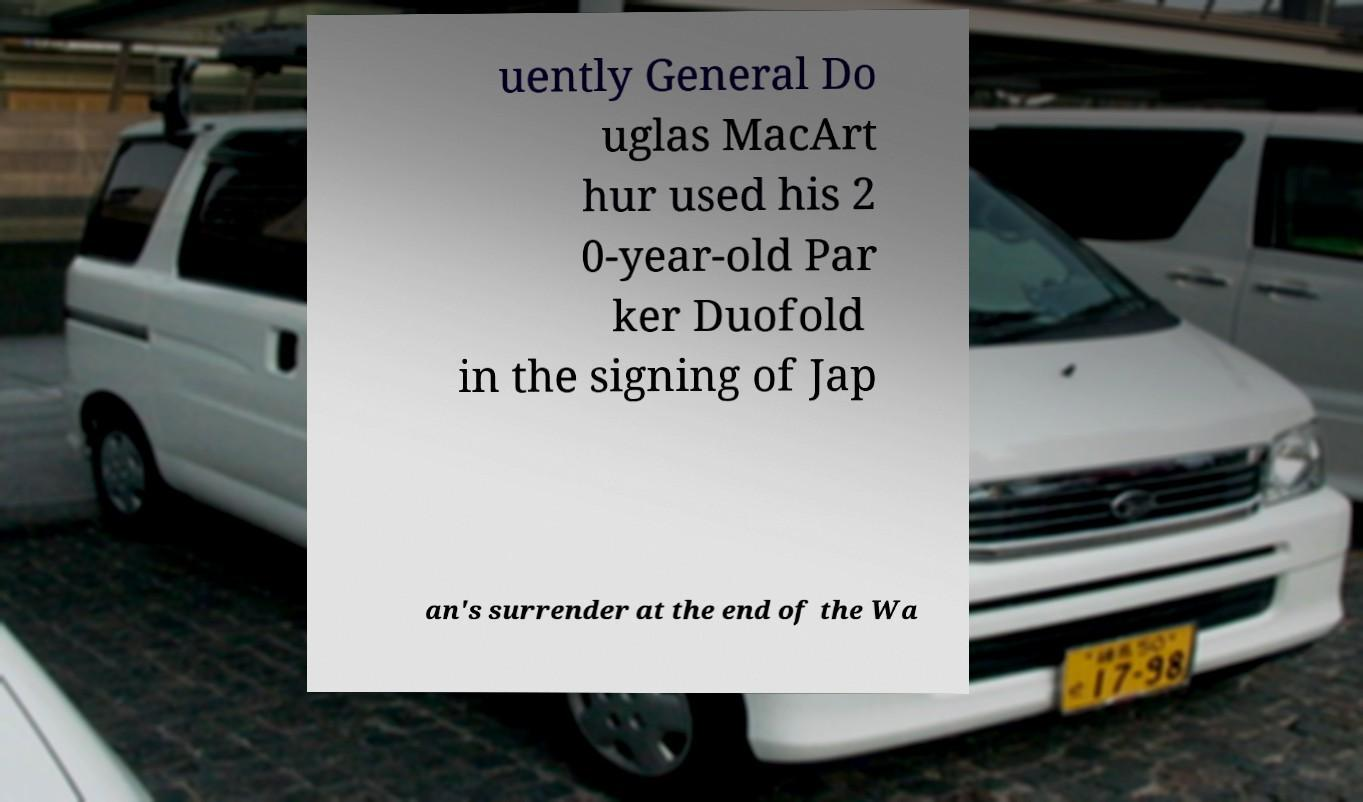I need the written content from this picture converted into text. Can you do that? uently General Do uglas MacArt hur used his 2 0-year-old Par ker Duofold in the signing of Jap an's surrender at the end of the Wa 